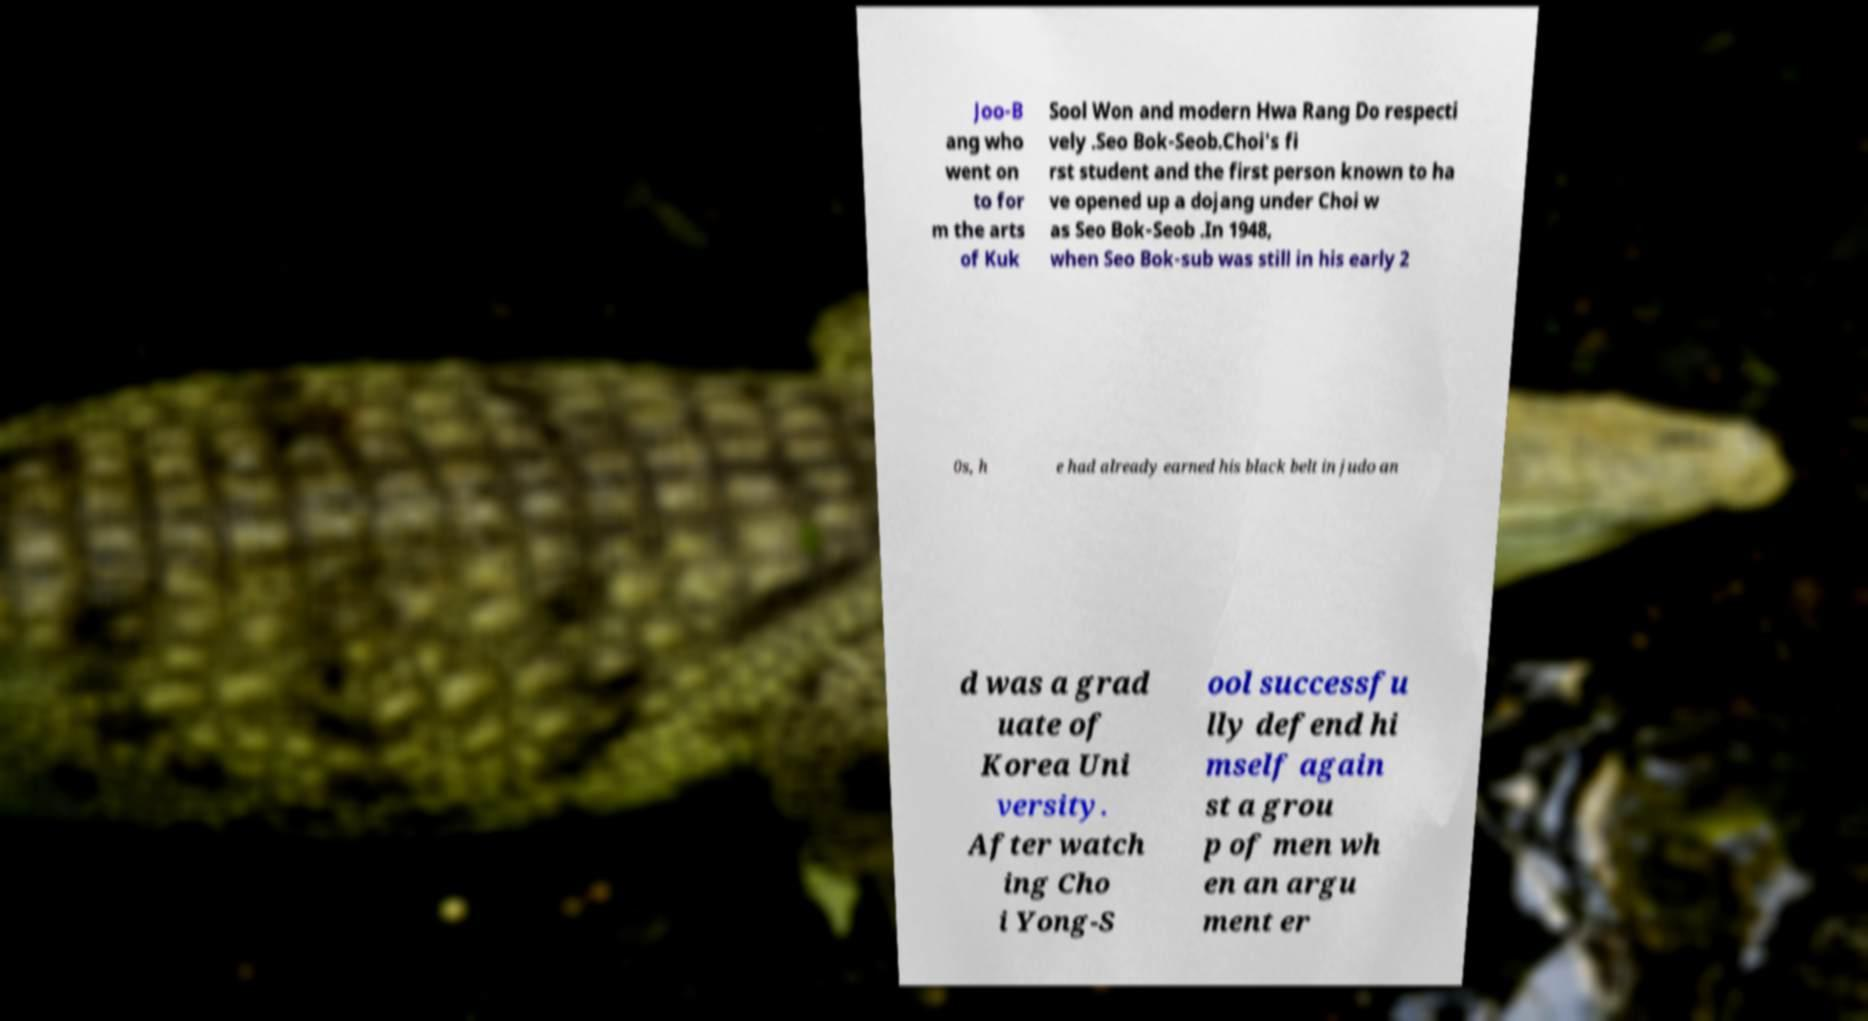I need the written content from this picture converted into text. Can you do that? Joo-B ang who went on to for m the arts of Kuk Sool Won and modern Hwa Rang Do respecti vely .Seo Bok-Seob.Choi's fi rst student and the first person known to ha ve opened up a dojang under Choi w as Seo Bok-Seob .In 1948, when Seo Bok-sub was still in his early 2 0s, h e had already earned his black belt in judo an d was a grad uate of Korea Uni versity. After watch ing Cho i Yong-S ool successfu lly defend hi mself again st a grou p of men wh en an argu ment er 